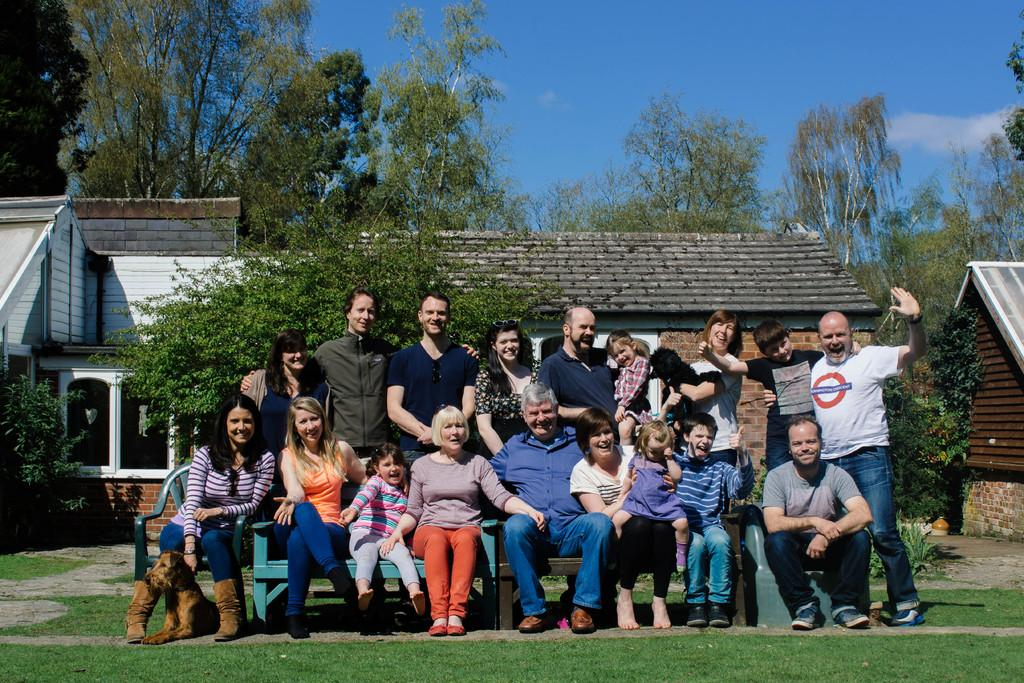What are the people in the image doing? The people in the image are sitting on chairs and posing for a picture. Are there any other people in the image besides those sitting on chairs? Yes, some people are standing behind the seated individuals. What can be seen in the background of the image? There are buildings, trees, and the sky visible in the background of the image. What type of muscle is being flexed by the person holding a rifle in the image? There is no person holding a rifle in the image, nor is there any muscle flexing. 